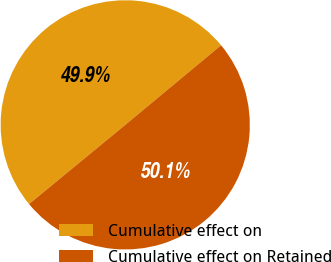Convert chart to OTSL. <chart><loc_0><loc_0><loc_500><loc_500><pie_chart><fcel>Cumulative effect on<fcel>Cumulative effect on Retained<nl><fcel>49.93%<fcel>50.07%<nl></chart> 